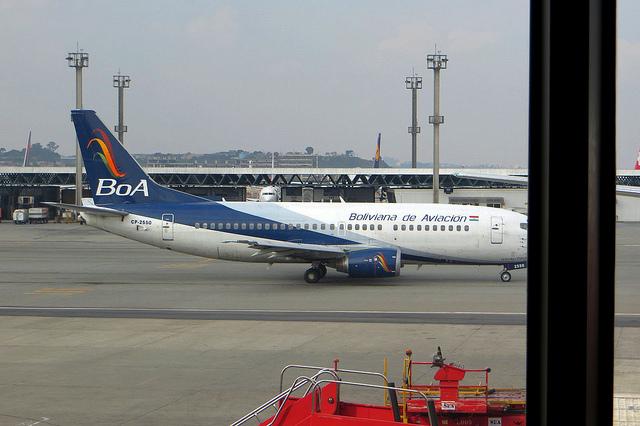How many planes are there?
Give a very brief answer. 1. How many tail fins are in this picture?
Keep it brief. 1. What is company printed on the plane?
Answer briefly. Boa. What airline is shown?
Concise answer only. Boa. What substance-abuse recovery organization is represented by the same letters on the plane's tail?
Quick response, please. Boa. What is the name of the Airways?
Be succinct. Boa. Which airline do these planes belong to?
Write a very short answer. Boa. What is the name of the Airline Company?
Write a very short answer. Boa. Does this item appear to be lovingly restored?
Give a very brief answer. No. Is there any people in this picture?
Be succinct. No. Is there water in front of the plane?
Be succinct. No. 